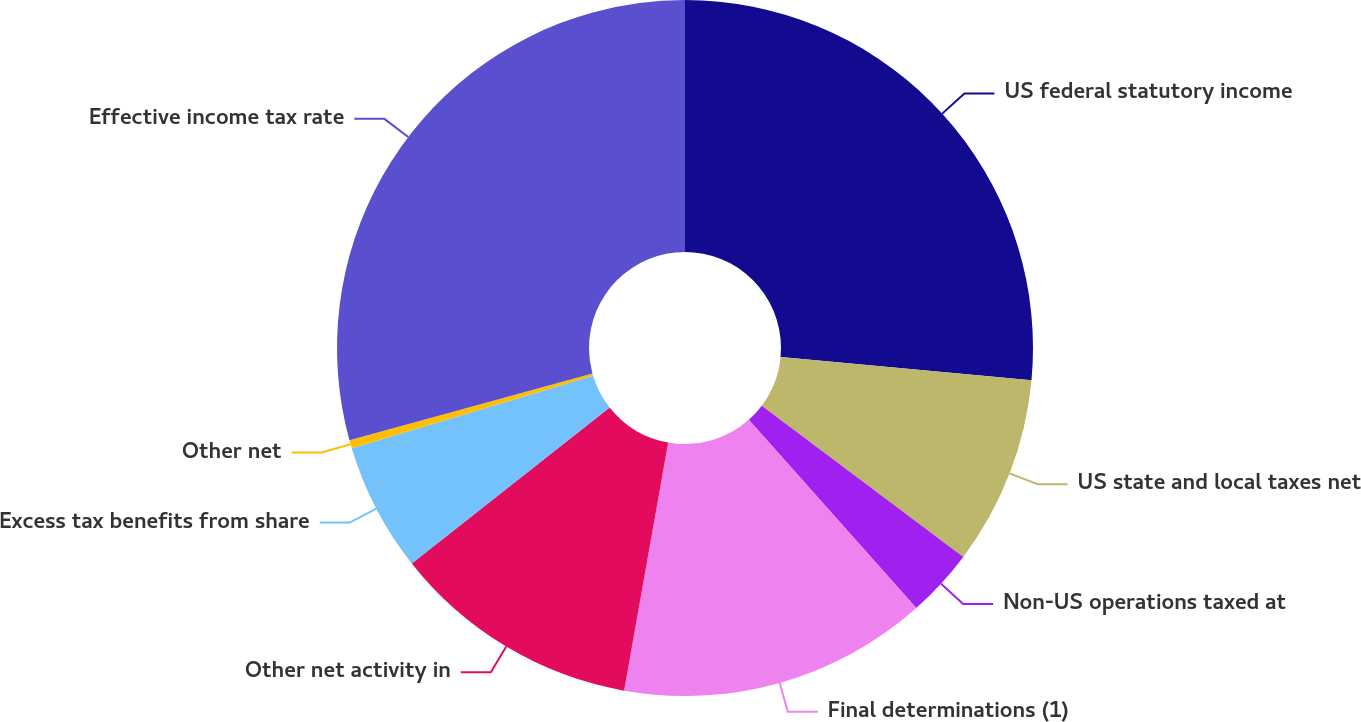Convert chart. <chart><loc_0><loc_0><loc_500><loc_500><pie_chart><fcel>US federal statutory income<fcel>US state and local taxes net<fcel>Non-US operations taxed at<fcel>Final determinations (1)<fcel>Other net activity in<fcel>Excess tax benefits from share<fcel>Other net<fcel>Effective income tax rate<nl><fcel>26.48%<fcel>8.77%<fcel>3.18%<fcel>14.37%<fcel>11.57%<fcel>5.98%<fcel>0.38%<fcel>29.27%<nl></chart> 